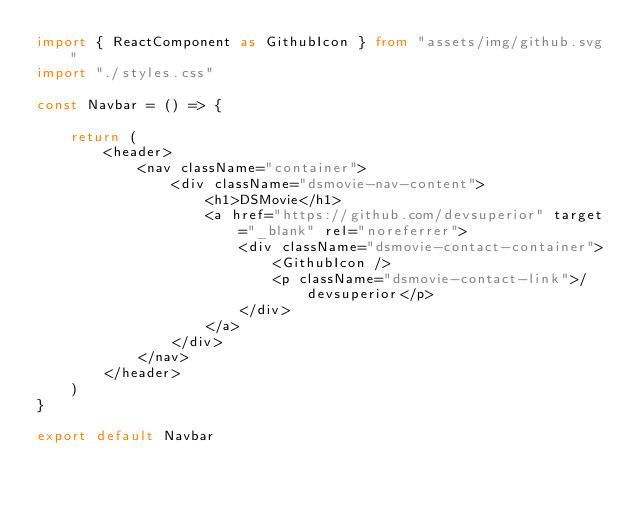<code> <loc_0><loc_0><loc_500><loc_500><_TypeScript_>import { ReactComponent as GithubIcon } from "assets/img/github.svg"
import "./styles.css"

const Navbar = () => {

    return (
        <header>
            <nav className="container">
                <div className="dsmovie-nav-content">
                    <h1>DSMovie</h1>
                    <a href="https://github.com/devsuperior" target="_blank" rel="noreferrer">
                        <div className="dsmovie-contact-container">
                            <GithubIcon />
                            <p className="dsmovie-contact-link">/devsuperior</p>
                        </div>
                    </a>
                </div>
            </nav>
        </header>
    )
}

export default Navbar</code> 